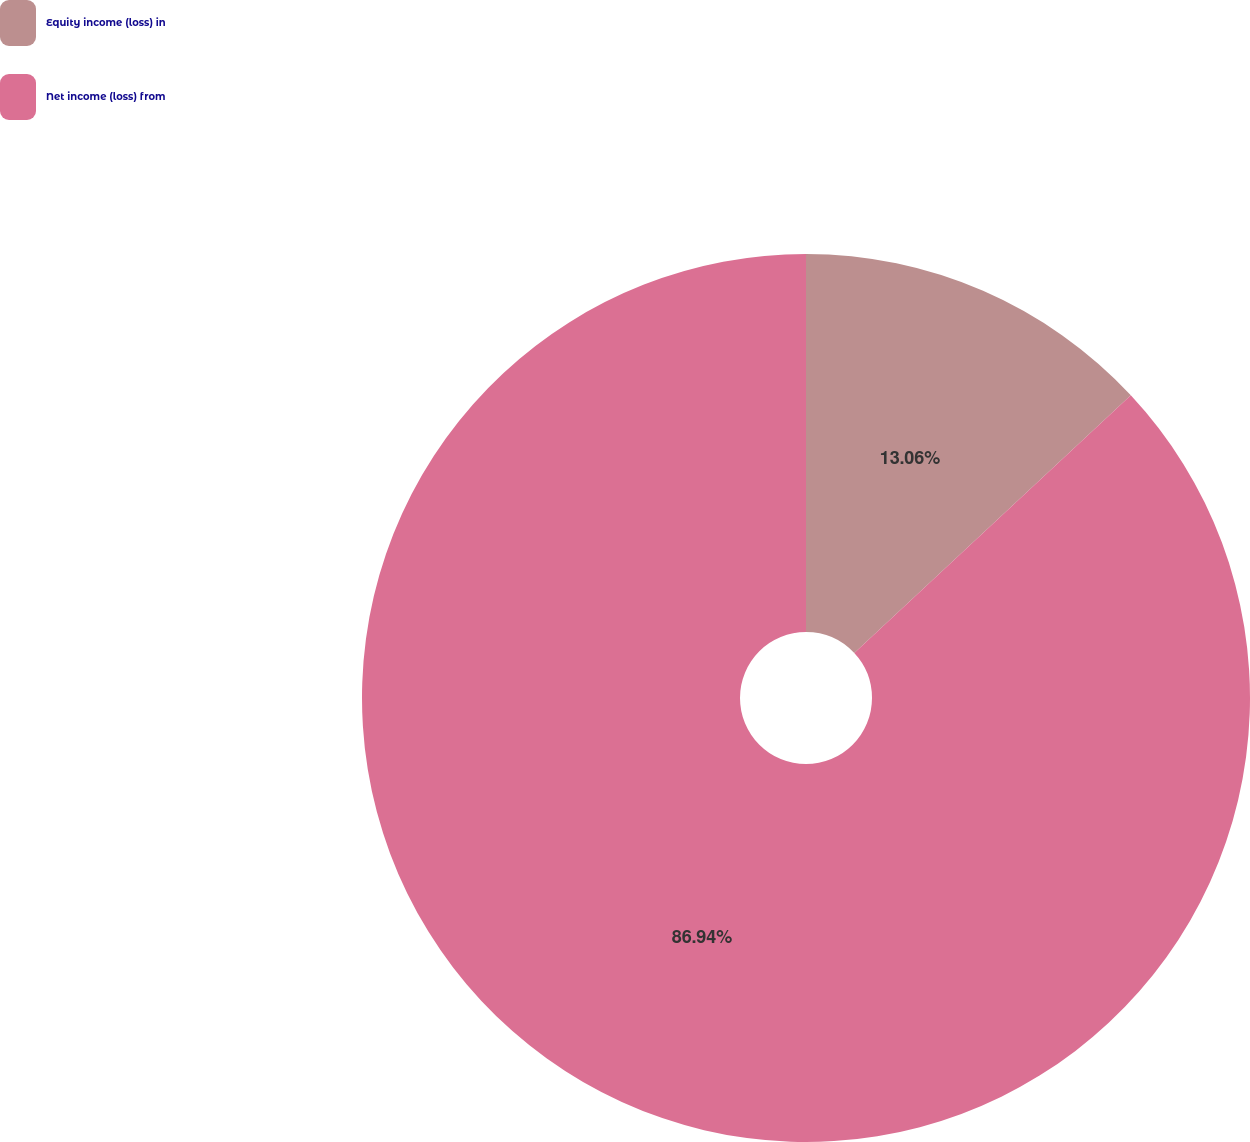Convert chart to OTSL. <chart><loc_0><loc_0><loc_500><loc_500><pie_chart><fcel>Equity income (loss) in<fcel>Net income (loss) from<nl><fcel>13.06%<fcel>86.94%<nl></chart> 